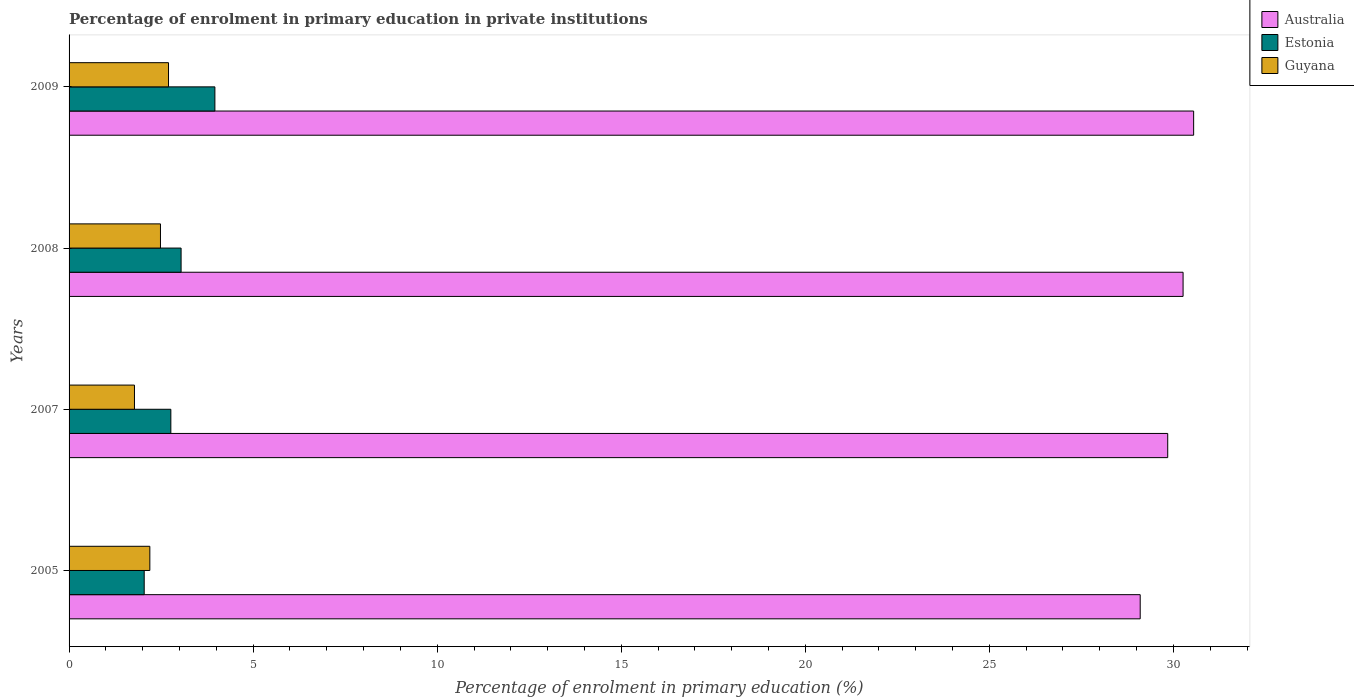How many different coloured bars are there?
Ensure brevity in your answer.  3. How many groups of bars are there?
Give a very brief answer. 4. Are the number of bars per tick equal to the number of legend labels?
Offer a very short reply. Yes. In how many cases, is the number of bars for a given year not equal to the number of legend labels?
Keep it short and to the point. 0. What is the percentage of enrolment in primary education in Australia in 2008?
Offer a very short reply. 30.26. Across all years, what is the maximum percentage of enrolment in primary education in Estonia?
Your response must be concise. 3.96. Across all years, what is the minimum percentage of enrolment in primary education in Estonia?
Provide a short and direct response. 2.04. In which year was the percentage of enrolment in primary education in Australia maximum?
Offer a terse response. 2009. What is the total percentage of enrolment in primary education in Guyana in the graph?
Keep it short and to the point. 9.16. What is the difference between the percentage of enrolment in primary education in Australia in 2005 and that in 2009?
Give a very brief answer. -1.45. What is the difference between the percentage of enrolment in primary education in Estonia in 2005 and the percentage of enrolment in primary education in Guyana in 2008?
Offer a terse response. -0.44. What is the average percentage of enrolment in primary education in Estonia per year?
Provide a short and direct response. 2.95. In the year 2008, what is the difference between the percentage of enrolment in primary education in Guyana and percentage of enrolment in primary education in Estonia?
Give a very brief answer. -0.56. In how many years, is the percentage of enrolment in primary education in Estonia greater than 30 %?
Your answer should be very brief. 0. What is the ratio of the percentage of enrolment in primary education in Guyana in 2005 to that in 2007?
Offer a very short reply. 1.24. Is the percentage of enrolment in primary education in Guyana in 2005 less than that in 2008?
Make the answer very short. Yes. Is the difference between the percentage of enrolment in primary education in Guyana in 2007 and 2008 greater than the difference between the percentage of enrolment in primary education in Estonia in 2007 and 2008?
Give a very brief answer. No. What is the difference between the highest and the second highest percentage of enrolment in primary education in Australia?
Make the answer very short. 0.29. What is the difference between the highest and the lowest percentage of enrolment in primary education in Guyana?
Offer a very short reply. 0.92. In how many years, is the percentage of enrolment in primary education in Australia greater than the average percentage of enrolment in primary education in Australia taken over all years?
Keep it short and to the point. 2. What does the 3rd bar from the top in 2009 represents?
Keep it short and to the point. Australia. What does the 3rd bar from the bottom in 2007 represents?
Offer a very short reply. Guyana. How many bars are there?
Your response must be concise. 12. What is the difference between two consecutive major ticks on the X-axis?
Make the answer very short. 5. Does the graph contain grids?
Your response must be concise. No. Where does the legend appear in the graph?
Your answer should be very brief. Top right. What is the title of the graph?
Offer a terse response. Percentage of enrolment in primary education in private institutions. What is the label or title of the X-axis?
Your response must be concise. Percentage of enrolment in primary education (%). What is the Percentage of enrolment in primary education (%) of Australia in 2005?
Offer a very short reply. 29.1. What is the Percentage of enrolment in primary education (%) in Estonia in 2005?
Offer a very short reply. 2.04. What is the Percentage of enrolment in primary education (%) of Guyana in 2005?
Offer a very short reply. 2.19. What is the Percentage of enrolment in primary education (%) of Australia in 2007?
Offer a terse response. 29.85. What is the Percentage of enrolment in primary education (%) of Estonia in 2007?
Your answer should be compact. 2.76. What is the Percentage of enrolment in primary education (%) in Guyana in 2007?
Keep it short and to the point. 1.78. What is the Percentage of enrolment in primary education (%) in Australia in 2008?
Ensure brevity in your answer.  30.26. What is the Percentage of enrolment in primary education (%) of Estonia in 2008?
Ensure brevity in your answer.  3.04. What is the Percentage of enrolment in primary education (%) of Guyana in 2008?
Ensure brevity in your answer.  2.48. What is the Percentage of enrolment in primary education (%) in Australia in 2009?
Provide a short and direct response. 30.55. What is the Percentage of enrolment in primary education (%) in Estonia in 2009?
Offer a terse response. 3.96. What is the Percentage of enrolment in primary education (%) of Guyana in 2009?
Your answer should be very brief. 2.7. Across all years, what is the maximum Percentage of enrolment in primary education (%) of Australia?
Your answer should be very brief. 30.55. Across all years, what is the maximum Percentage of enrolment in primary education (%) in Estonia?
Your response must be concise. 3.96. Across all years, what is the maximum Percentage of enrolment in primary education (%) of Guyana?
Ensure brevity in your answer.  2.7. Across all years, what is the minimum Percentage of enrolment in primary education (%) in Australia?
Your answer should be very brief. 29.1. Across all years, what is the minimum Percentage of enrolment in primary education (%) of Estonia?
Offer a very short reply. 2.04. Across all years, what is the minimum Percentage of enrolment in primary education (%) of Guyana?
Offer a terse response. 1.78. What is the total Percentage of enrolment in primary education (%) in Australia in the graph?
Give a very brief answer. 119.76. What is the total Percentage of enrolment in primary education (%) of Estonia in the graph?
Your answer should be compact. 11.81. What is the total Percentage of enrolment in primary education (%) in Guyana in the graph?
Your answer should be very brief. 9.16. What is the difference between the Percentage of enrolment in primary education (%) in Australia in 2005 and that in 2007?
Provide a short and direct response. -0.75. What is the difference between the Percentage of enrolment in primary education (%) of Estonia in 2005 and that in 2007?
Provide a succinct answer. -0.72. What is the difference between the Percentage of enrolment in primary education (%) of Guyana in 2005 and that in 2007?
Offer a terse response. 0.42. What is the difference between the Percentage of enrolment in primary education (%) of Australia in 2005 and that in 2008?
Offer a terse response. -1.16. What is the difference between the Percentage of enrolment in primary education (%) in Estonia in 2005 and that in 2008?
Your answer should be very brief. -1. What is the difference between the Percentage of enrolment in primary education (%) of Guyana in 2005 and that in 2008?
Your response must be concise. -0.29. What is the difference between the Percentage of enrolment in primary education (%) of Australia in 2005 and that in 2009?
Keep it short and to the point. -1.45. What is the difference between the Percentage of enrolment in primary education (%) in Estonia in 2005 and that in 2009?
Provide a succinct answer. -1.92. What is the difference between the Percentage of enrolment in primary education (%) of Guyana in 2005 and that in 2009?
Your response must be concise. -0.51. What is the difference between the Percentage of enrolment in primary education (%) in Australia in 2007 and that in 2008?
Provide a succinct answer. -0.42. What is the difference between the Percentage of enrolment in primary education (%) in Estonia in 2007 and that in 2008?
Offer a terse response. -0.28. What is the difference between the Percentage of enrolment in primary education (%) in Guyana in 2007 and that in 2008?
Your response must be concise. -0.71. What is the difference between the Percentage of enrolment in primary education (%) of Australia in 2007 and that in 2009?
Make the answer very short. -0.7. What is the difference between the Percentage of enrolment in primary education (%) of Estonia in 2007 and that in 2009?
Your answer should be compact. -1.2. What is the difference between the Percentage of enrolment in primary education (%) of Guyana in 2007 and that in 2009?
Keep it short and to the point. -0.92. What is the difference between the Percentage of enrolment in primary education (%) of Australia in 2008 and that in 2009?
Keep it short and to the point. -0.29. What is the difference between the Percentage of enrolment in primary education (%) in Estonia in 2008 and that in 2009?
Keep it short and to the point. -0.92. What is the difference between the Percentage of enrolment in primary education (%) in Guyana in 2008 and that in 2009?
Offer a very short reply. -0.22. What is the difference between the Percentage of enrolment in primary education (%) in Australia in 2005 and the Percentage of enrolment in primary education (%) in Estonia in 2007?
Provide a short and direct response. 26.33. What is the difference between the Percentage of enrolment in primary education (%) of Australia in 2005 and the Percentage of enrolment in primary education (%) of Guyana in 2007?
Provide a short and direct response. 27.32. What is the difference between the Percentage of enrolment in primary education (%) of Estonia in 2005 and the Percentage of enrolment in primary education (%) of Guyana in 2007?
Provide a short and direct response. 0.26. What is the difference between the Percentage of enrolment in primary education (%) of Australia in 2005 and the Percentage of enrolment in primary education (%) of Estonia in 2008?
Ensure brevity in your answer.  26.05. What is the difference between the Percentage of enrolment in primary education (%) of Australia in 2005 and the Percentage of enrolment in primary education (%) of Guyana in 2008?
Provide a succinct answer. 26.62. What is the difference between the Percentage of enrolment in primary education (%) in Estonia in 2005 and the Percentage of enrolment in primary education (%) in Guyana in 2008?
Give a very brief answer. -0.44. What is the difference between the Percentage of enrolment in primary education (%) in Australia in 2005 and the Percentage of enrolment in primary education (%) in Estonia in 2009?
Give a very brief answer. 25.14. What is the difference between the Percentage of enrolment in primary education (%) of Australia in 2005 and the Percentage of enrolment in primary education (%) of Guyana in 2009?
Offer a very short reply. 26.4. What is the difference between the Percentage of enrolment in primary education (%) of Estonia in 2005 and the Percentage of enrolment in primary education (%) of Guyana in 2009?
Ensure brevity in your answer.  -0.66. What is the difference between the Percentage of enrolment in primary education (%) in Australia in 2007 and the Percentage of enrolment in primary education (%) in Estonia in 2008?
Provide a short and direct response. 26.8. What is the difference between the Percentage of enrolment in primary education (%) of Australia in 2007 and the Percentage of enrolment in primary education (%) of Guyana in 2008?
Your answer should be compact. 27.36. What is the difference between the Percentage of enrolment in primary education (%) of Estonia in 2007 and the Percentage of enrolment in primary education (%) of Guyana in 2008?
Provide a short and direct response. 0.28. What is the difference between the Percentage of enrolment in primary education (%) in Australia in 2007 and the Percentage of enrolment in primary education (%) in Estonia in 2009?
Your answer should be compact. 25.88. What is the difference between the Percentage of enrolment in primary education (%) in Australia in 2007 and the Percentage of enrolment in primary education (%) in Guyana in 2009?
Give a very brief answer. 27.14. What is the difference between the Percentage of enrolment in primary education (%) in Estonia in 2007 and the Percentage of enrolment in primary education (%) in Guyana in 2009?
Your answer should be very brief. 0.06. What is the difference between the Percentage of enrolment in primary education (%) in Australia in 2008 and the Percentage of enrolment in primary education (%) in Estonia in 2009?
Provide a succinct answer. 26.3. What is the difference between the Percentage of enrolment in primary education (%) of Australia in 2008 and the Percentage of enrolment in primary education (%) of Guyana in 2009?
Offer a very short reply. 27.56. What is the difference between the Percentage of enrolment in primary education (%) of Estonia in 2008 and the Percentage of enrolment in primary education (%) of Guyana in 2009?
Ensure brevity in your answer.  0.34. What is the average Percentage of enrolment in primary education (%) in Australia per year?
Make the answer very short. 29.94. What is the average Percentage of enrolment in primary education (%) in Estonia per year?
Your answer should be compact. 2.95. What is the average Percentage of enrolment in primary education (%) in Guyana per year?
Offer a very short reply. 2.29. In the year 2005, what is the difference between the Percentage of enrolment in primary education (%) of Australia and Percentage of enrolment in primary education (%) of Estonia?
Give a very brief answer. 27.06. In the year 2005, what is the difference between the Percentage of enrolment in primary education (%) of Australia and Percentage of enrolment in primary education (%) of Guyana?
Provide a succinct answer. 26.9. In the year 2005, what is the difference between the Percentage of enrolment in primary education (%) of Estonia and Percentage of enrolment in primary education (%) of Guyana?
Your response must be concise. -0.15. In the year 2007, what is the difference between the Percentage of enrolment in primary education (%) of Australia and Percentage of enrolment in primary education (%) of Estonia?
Provide a short and direct response. 27.08. In the year 2007, what is the difference between the Percentage of enrolment in primary education (%) in Australia and Percentage of enrolment in primary education (%) in Guyana?
Give a very brief answer. 28.07. In the year 2007, what is the difference between the Percentage of enrolment in primary education (%) of Estonia and Percentage of enrolment in primary education (%) of Guyana?
Provide a short and direct response. 0.99. In the year 2008, what is the difference between the Percentage of enrolment in primary education (%) in Australia and Percentage of enrolment in primary education (%) in Estonia?
Give a very brief answer. 27.22. In the year 2008, what is the difference between the Percentage of enrolment in primary education (%) in Australia and Percentage of enrolment in primary education (%) in Guyana?
Your response must be concise. 27.78. In the year 2008, what is the difference between the Percentage of enrolment in primary education (%) in Estonia and Percentage of enrolment in primary education (%) in Guyana?
Offer a very short reply. 0.56. In the year 2009, what is the difference between the Percentage of enrolment in primary education (%) in Australia and Percentage of enrolment in primary education (%) in Estonia?
Offer a very short reply. 26.59. In the year 2009, what is the difference between the Percentage of enrolment in primary education (%) in Australia and Percentage of enrolment in primary education (%) in Guyana?
Your response must be concise. 27.85. In the year 2009, what is the difference between the Percentage of enrolment in primary education (%) in Estonia and Percentage of enrolment in primary education (%) in Guyana?
Make the answer very short. 1.26. What is the ratio of the Percentage of enrolment in primary education (%) of Australia in 2005 to that in 2007?
Provide a succinct answer. 0.97. What is the ratio of the Percentage of enrolment in primary education (%) in Estonia in 2005 to that in 2007?
Give a very brief answer. 0.74. What is the ratio of the Percentage of enrolment in primary education (%) of Guyana in 2005 to that in 2007?
Provide a short and direct response. 1.24. What is the ratio of the Percentage of enrolment in primary education (%) in Australia in 2005 to that in 2008?
Your answer should be compact. 0.96. What is the ratio of the Percentage of enrolment in primary education (%) of Estonia in 2005 to that in 2008?
Keep it short and to the point. 0.67. What is the ratio of the Percentage of enrolment in primary education (%) in Guyana in 2005 to that in 2008?
Offer a very short reply. 0.88. What is the ratio of the Percentage of enrolment in primary education (%) of Australia in 2005 to that in 2009?
Your response must be concise. 0.95. What is the ratio of the Percentage of enrolment in primary education (%) of Estonia in 2005 to that in 2009?
Your answer should be very brief. 0.52. What is the ratio of the Percentage of enrolment in primary education (%) of Guyana in 2005 to that in 2009?
Offer a terse response. 0.81. What is the ratio of the Percentage of enrolment in primary education (%) of Australia in 2007 to that in 2008?
Give a very brief answer. 0.99. What is the ratio of the Percentage of enrolment in primary education (%) in Estonia in 2007 to that in 2008?
Your answer should be very brief. 0.91. What is the ratio of the Percentage of enrolment in primary education (%) of Guyana in 2007 to that in 2008?
Give a very brief answer. 0.72. What is the ratio of the Percentage of enrolment in primary education (%) of Estonia in 2007 to that in 2009?
Your answer should be compact. 0.7. What is the ratio of the Percentage of enrolment in primary education (%) in Guyana in 2007 to that in 2009?
Provide a succinct answer. 0.66. What is the ratio of the Percentage of enrolment in primary education (%) of Australia in 2008 to that in 2009?
Provide a short and direct response. 0.99. What is the ratio of the Percentage of enrolment in primary education (%) in Estonia in 2008 to that in 2009?
Provide a short and direct response. 0.77. What is the ratio of the Percentage of enrolment in primary education (%) in Guyana in 2008 to that in 2009?
Your answer should be very brief. 0.92. What is the difference between the highest and the second highest Percentage of enrolment in primary education (%) in Australia?
Your answer should be very brief. 0.29. What is the difference between the highest and the second highest Percentage of enrolment in primary education (%) in Estonia?
Your answer should be very brief. 0.92. What is the difference between the highest and the second highest Percentage of enrolment in primary education (%) of Guyana?
Ensure brevity in your answer.  0.22. What is the difference between the highest and the lowest Percentage of enrolment in primary education (%) in Australia?
Ensure brevity in your answer.  1.45. What is the difference between the highest and the lowest Percentage of enrolment in primary education (%) of Estonia?
Make the answer very short. 1.92. What is the difference between the highest and the lowest Percentage of enrolment in primary education (%) of Guyana?
Ensure brevity in your answer.  0.92. 